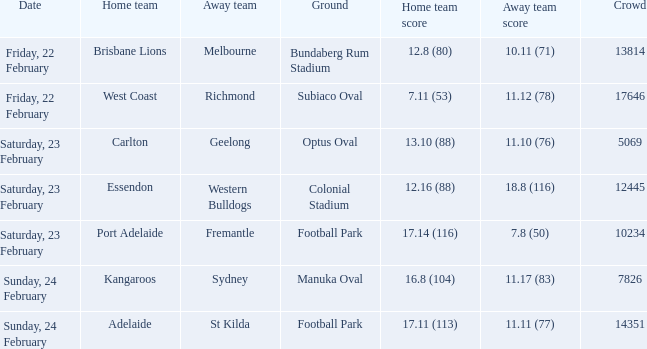What score did the away team receive against home team Port Adelaide? 7.8 (50). 